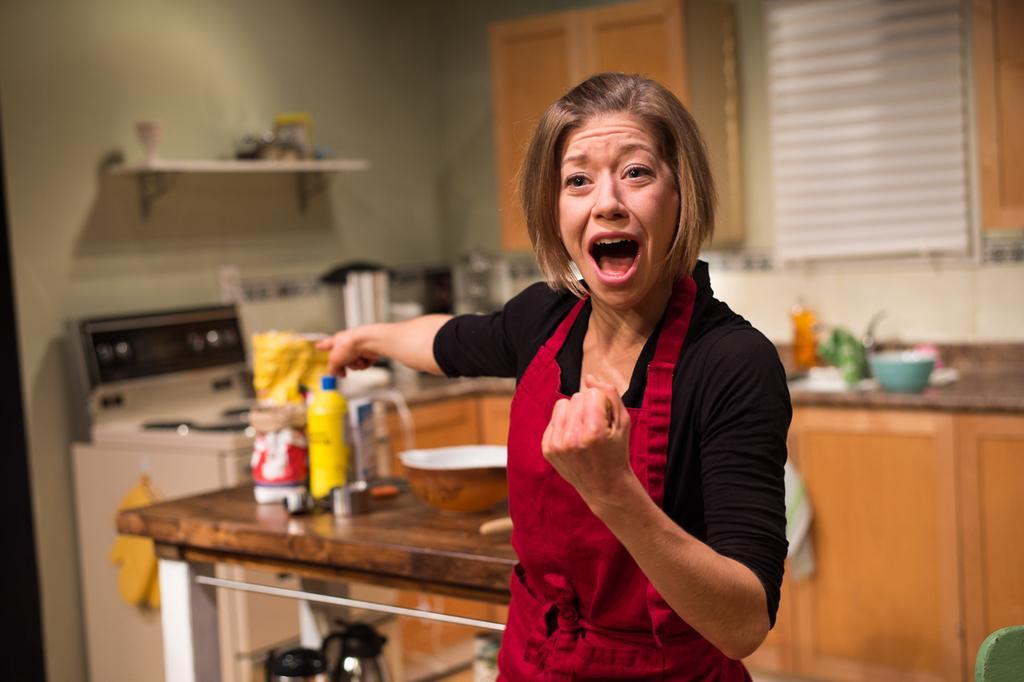In one or two sentences, can you explain what this image depicts? In the foreground of the picture there is a woman, behind her it is kitchen. The background is blurred. In the background there are bowls, stove, closet, windows, jars, and other kitchen utensils. 